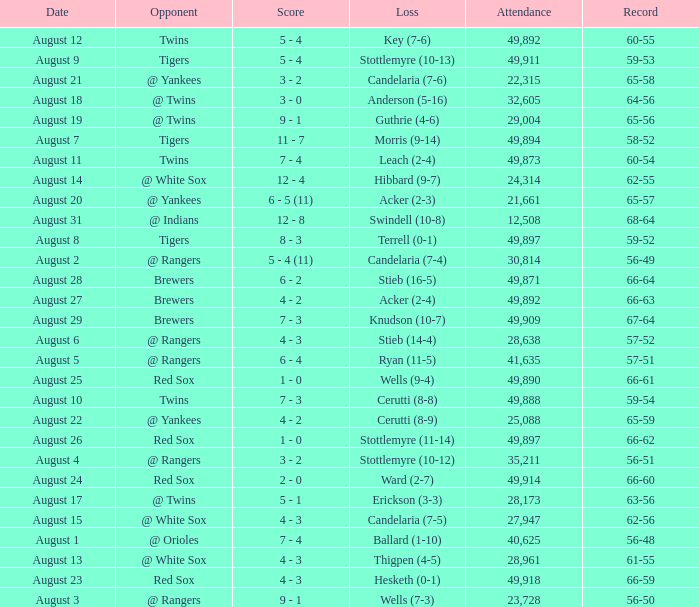Could you parse the entire table as a dict? {'header': ['Date', 'Opponent', 'Score', 'Loss', 'Attendance', 'Record'], 'rows': [['August 12', 'Twins', '5 - 4', 'Key (7-6)', '49,892', '60-55'], ['August 9', 'Tigers', '5 - 4', 'Stottlemyre (10-13)', '49,911', '59-53'], ['August 21', '@ Yankees', '3 - 2', 'Candelaria (7-6)', '22,315', '65-58'], ['August 18', '@ Twins', '3 - 0', 'Anderson (5-16)', '32,605', '64-56'], ['August 19', '@ Twins', '9 - 1', 'Guthrie (4-6)', '29,004', '65-56'], ['August 7', 'Tigers', '11 - 7', 'Morris (9-14)', '49,894', '58-52'], ['August 11', 'Twins', '7 - 4', 'Leach (2-4)', '49,873', '60-54'], ['August 14', '@ White Sox', '12 - 4', 'Hibbard (9-7)', '24,314', '62-55'], ['August 20', '@ Yankees', '6 - 5 (11)', 'Acker (2-3)', '21,661', '65-57'], ['August 31', '@ Indians', '12 - 8', 'Swindell (10-8)', '12,508', '68-64'], ['August 8', 'Tigers', '8 - 3', 'Terrell (0-1)', '49,897', '59-52'], ['August 2', '@ Rangers', '5 - 4 (11)', 'Candelaria (7-4)', '30,814', '56-49'], ['August 28', 'Brewers', '6 - 2', 'Stieb (16-5)', '49,871', '66-64'], ['August 27', 'Brewers', '4 - 2', 'Acker (2-4)', '49,892', '66-63'], ['August 29', 'Brewers', '7 - 3', 'Knudson (10-7)', '49,909', '67-64'], ['August 6', '@ Rangers', '4 - 3', 'Stieb (14-4)', '28,638', '57-52'], ['August 5', '@ Rangers', '6 - 4', 'Ryan (11-5)', '41,635', '57-51'], ['August 25', 'Red Sox', '1 - 0', 'Wells (9-4)', '49,890', '66-61'], ['August 10', 'Twins', '7 - 3', 'Cerutti (8-8)', '49,888', '59-54'], ['August 22', '@ Yankees', '4 - 2', 'Cerutti (8-9)', '25,088', '65-59'], ['August 26', 'Red Sox', '1 - 0', 'Stottlemyre (11-14)', '49,897', '66-62'], ['August 4', '@ Rangers', '3 - 2', 'Stottlemyre (10-12)', '35,211', '56-51'], ['August 24', 'Red Sox', '2 - 0', 'Ward (2-7)', '49,914', '66-60'], ['August 17', '@ Twins', '5 - 1', 'Erickson (3-3)', '28,173', '63-56'], ['August 15', '@ White Sox', '4 - 3', 'Candelaria (7-5)', '27,947', '62-56'], ['August 1', '@ Orioles', '7 - 4', 'Ballard (1-10)', '40,625', '56-48'], ['August 13', '@ White Sox', '4 - 3', 'Thigpen (4-5)', '28,961', '61-55'], ['August 23', 'Red Sox', '4 - 3', 'Hesketh (0-1)', '49,918', '66-59'], ['August 3', '@ Rangers', '9 - 1', 'Wells (7-3)', '23,728', '56-50']]} What was the Attendance high on August 28? 49871.0. 